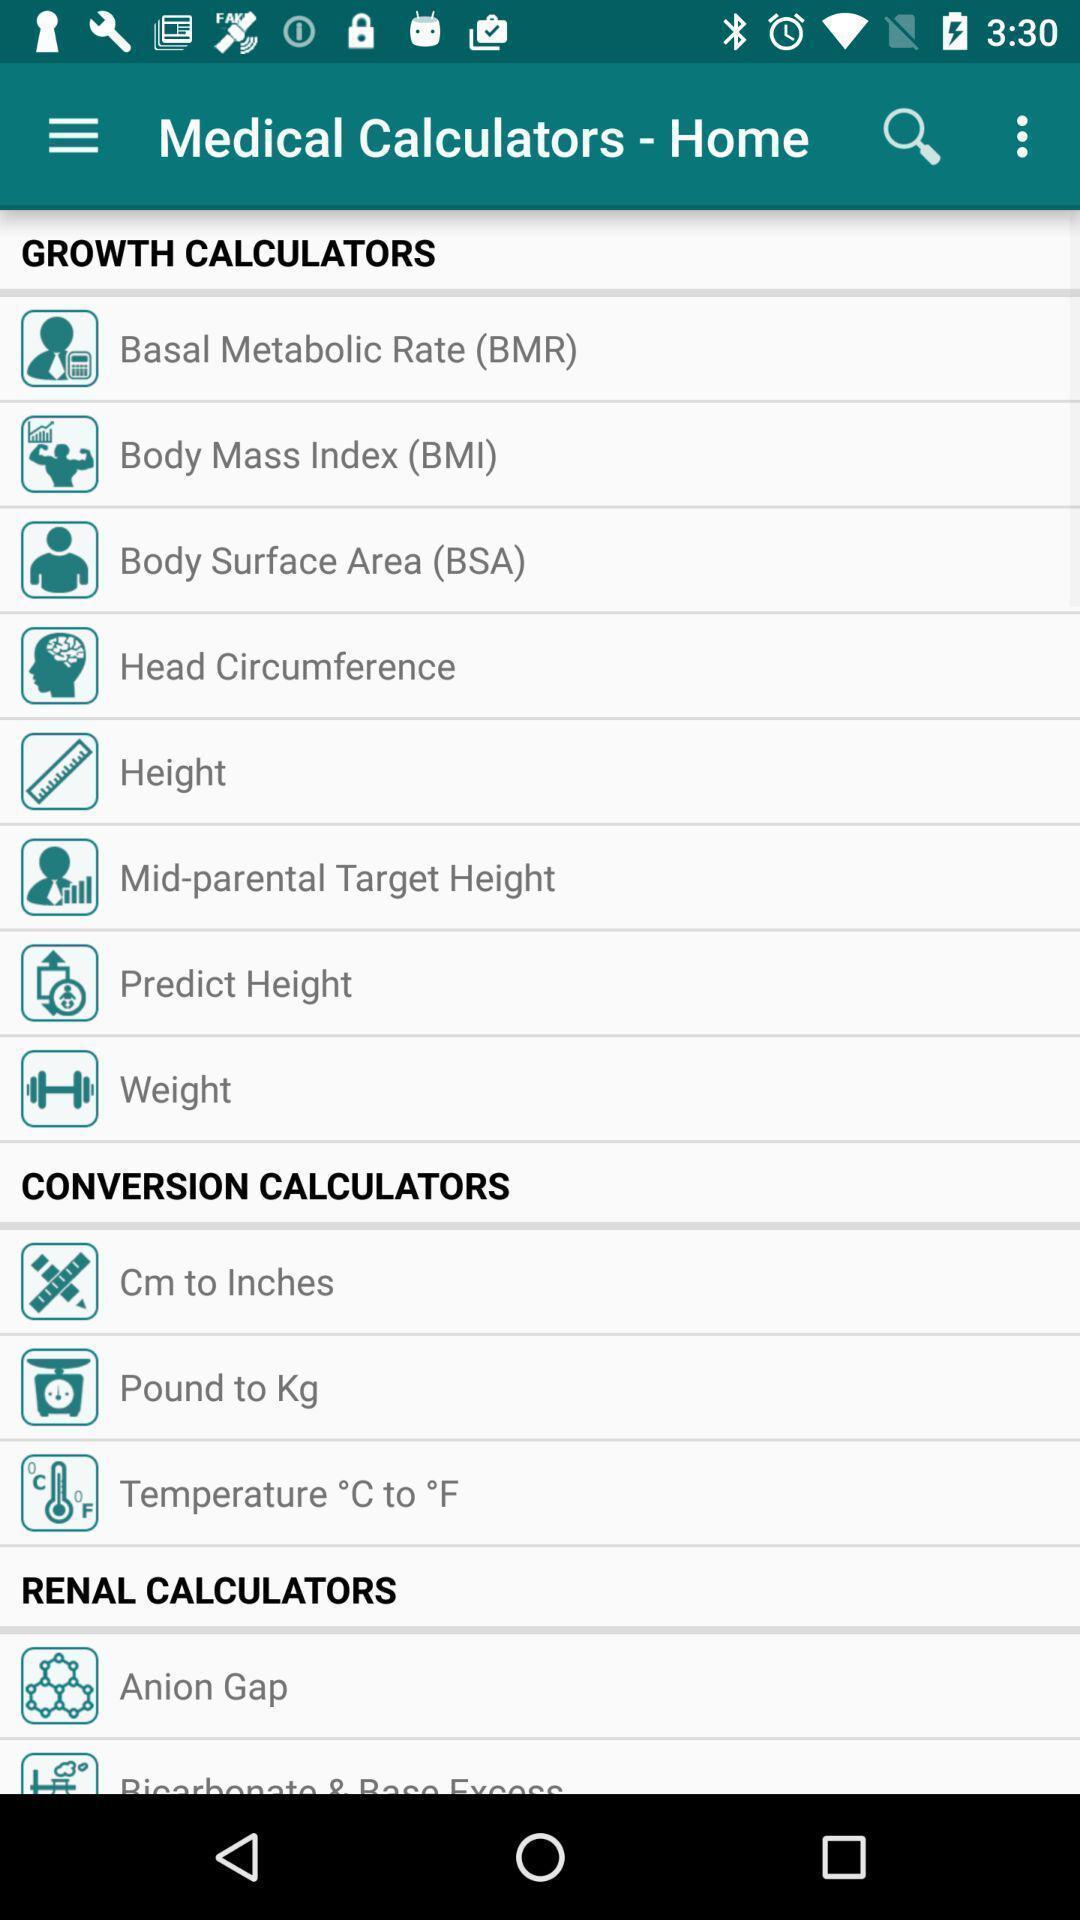Tell me about the visual elements in this screen capture. Screen page displaying various calculator categories. 